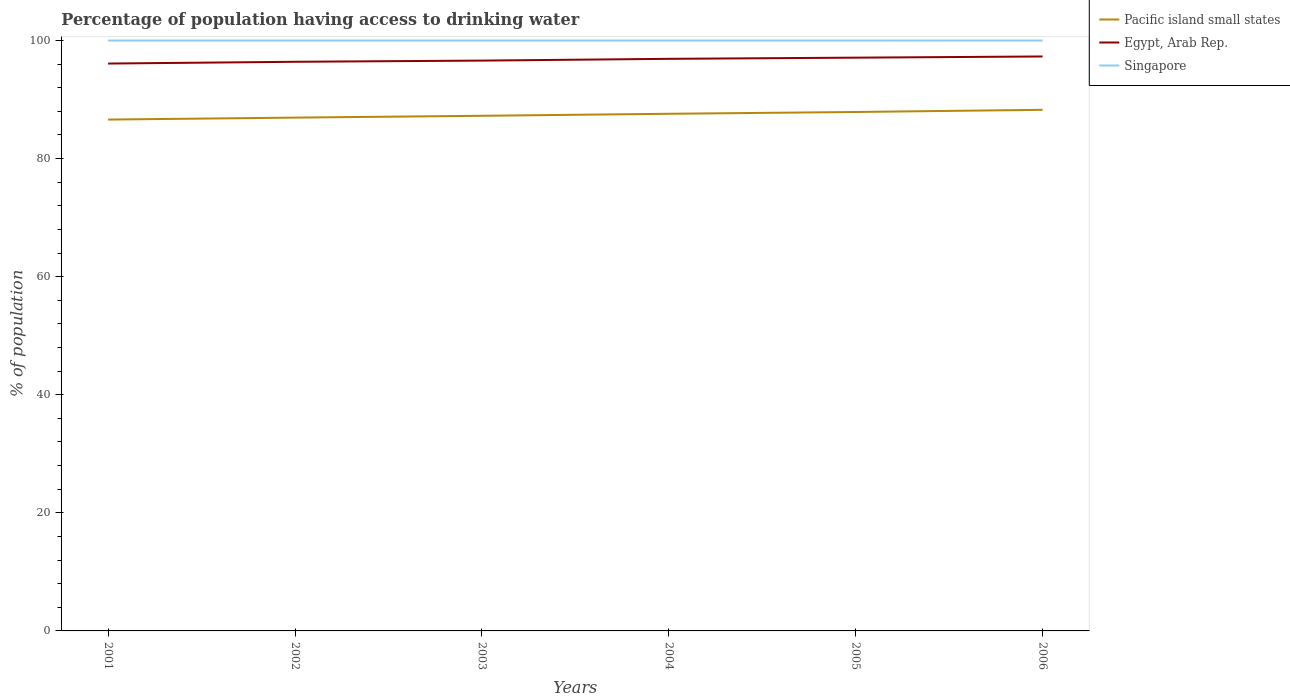Does the line corresponding to Egypt, Arab Rep. intersect with the line corresponding to Singapore?
Offer a terse response. No. Is the number of lines equal to the number of legend labels?
Offer a very short reply. Yes. Across all years, what is the maximum percentage of population having access to drinking water in Pacific island small states?
Make the answer very short. 86.61. What is the total percentage of population having access to drinking water in Egypt, Arab Rep. in the graph?
Provide a short and direct response. -0.8. What is the difference between the highest and the second highest percentage of population having access to drinking water in Egypt, Arab Rep.?
Provide a succinct answer. 1.2. Does the graph contain any zero values?
Your answer should be compact. No. What is the title of the graph?
Provide a short and direct response. Percentage of population having access to drinking water. Does "Brazil" appear as one of the legend labels in the graph?
Your response must be concise. No. What is the label or title of the X-axis?
Offer a very short reply. Years. What is the label or title of the Y-axis?
Your answer should be very brief. % of population. What is the % of population in Pacific island small states in 2001?
Keep it short and to the point. 86.61. What is the % of population of Egypt, Arab Rep. in 2001?
Give a very brief answer. 96.1. What is the % of population in Pacific island small states in 2002?
Offer a terse response. 86.94. What is the % of population in Egypt, Arab Rep. in 2002?
Give a very brief answer. 96.4. What is the % of population of Pacific island small states in 2003?
Your answer should be very brief. 87.25. What is the % of population in Egypt, Arab Rep. in 2003?
Offer a very short reply. 96.6. What is the % of population in Singapore in 2003?
Offer a very short reply. 100. What is the % of population in Pacific island small states in 2004?
Provide a short and direct response. 87.59. What is the % of population in Egypt, Arab Rep. in 2004?
Provide a succinct answer. 96.9. What is the % of population of Pacific island small states in 2005?
Keep it short and to the point. 87.9. What is the % of population in Egypt, Arab Rep. in 2005?
Provide a succinct answer. 97.1. What is the % of population in Singapore in 2005?
Give a very brief answer. 100. What is the % of population of Pacific island small states in 2006?
Offer a very short reply. 88.26. What is the % of population in Egypt, Arab Rep. in 2006?
Make the answer very short. 97.3. What is the % of population in Singapore in 2006?
Your answer should be compact. 100. Across all years, what is the maximum % of population in Pacific island small states?
Your answer should be very brief. 88.26. Across all years, what is the maximum % of population in Egypt, Arab Rep.?
Provide a short and direct response. 97.3. Across all years, what is the maximum % of population of Singapore?
Offer a very short reply. 100. Across all years, what is the minimum % of population of Pacific island small states?
Provide a succinct answer. 86.61. Across all years, what is the minimum % of population of Egypt, Arab Rep.?
Keep it short and to the point. 96.1. Across all years, what is the minimum % of population in Singapore?
Offer a terse response. 100. What is the total % of population of Pacific island small states in the graph?
Provide a succinct answer. 524.56. What is the total % of population of Egypt, Arab Rep. in the graph?
Offer a very short reply. 580.4. What is the total % of population of Singapore in the graph?
Offer a terse response. 600. What is the difference between the % of population of Pacific island small states in 2001 and that in 2002?
Make the answer very short. -0.33. What is the difference between the % of population in Singapore in 2001 and that in 2002?
Keep it short and to the point. 0. What is the difference between the % of population in Pacific island small states in 2001 and that in 2003?
Your response must be concise. -0.64. What is the difference between the % of population of Pacific island small states in 2001 and that in 2004?
Make the answer very short. -0.98. What is the difference between the % of population in Egypt, Arab Rep. in 2001 and that in 2004?
Offer a terse response. -0.8. What is the difference between the % of population of Pacific island small states in 2001 and that in 2005?
Provide a short and direct response. -1.28. What is the difference between the % of population in Egypt, Arab Rep. in 2001 and that in 2005?
Your response must be concise. -1. What is the difference between the % of population in Singapore in 2001 and that in 2005?
Offer a very short reply. 0. What is the difference between the % of population in Pacific island small states in 2001 and that in 2006?
Make the answer very short. -1.65. What is the difference between the % of population of Singapore in 2001 and that in 2006?
Offer a terse response. 0. What is the difference between the % of population in Pacific island small states in 2002 and that in 2003?
Your answer should be very brief. -0.31. What is the difference between the % of population in Egypt, Arab Rep. in 2002 and that in 2003?
Keep it short and to the point. -0.2. What is the difference between the % of population of Pacific island small states in 2002 and that in 2004?
Keep it short and to the point. -0.65. What is the difference between the % of population in Egypt, Arab Rep. in 2002 and that in 2004?
Keep it short and to the point. -0.5. What is the difference between the % of population of Singapore in 2002 and that in 2004?
Your answer should be very brief. 0. What is the difference between the % of population in Pacific island small states in 2002 and that in 2005?
Offer a very short reply. -0.95. What is the difference between the % of population of Singapore in 2002 and that in 2005?
Offer a very short reply. 0. What is the difference between the % of population in Pacific island small states in 2002 and that in 2006?
Your answer should be compact. -1.32. What is the difference between the % of population of Egypt, Arab Rep. in 2002 and that in 2006?
Give a very brief answer. -0.9. What is the difference between the % of population in Singapore in 2002 and that in 2006?
Ensure brevity in your answer.  0. What is the difference between the % of population of Pacific island small states in 2003 and that in 2004?
Your response must be concise. -0.34. What is the difference between the % of population of Egypt, Arab Rep. in 2003 and that in 2004?
Give a very brief answer. -0.3. What is the difference between the % of population in Singapore in 2003 and that in 2004?
Provide a succinct answer. 0. What is the difference between the % of population in Pacific island small states in 2003 and that in 2005?
Your response must be concise. -0.64. What is the difference between the % of population in Singapore in 2003 and that in 2005?
Provide a short and direct response. 0. What is the difference between the % of population of Pacific island small states in 2003 and that in 2006?
Make the answer very short. -1.01. What is the difference between the % of population in Egypt, Arab Rep. in 2003 and that in 2006?
Your answer should be very brief. -0.7. What is the difference between the % of population of Singapore in 2003 and that in 2006?
Give a very brief answer. 0. What is the difference between the % of population in Pacific island small states in 2004 and that in 2005?
Offer a very short reply. -0.3. What is the difference between the % of population in Pacific island small states in 2004 and that in 2006?
Make the answer very short. -0.67. What is the difference between the % of population in Egypt, Arab Rep. in 2004 and that in 2006?
Make the answer very short. -0.4. What is the difference between the % of population in Singapore in 2004 and that in 2006?
Your answer should be very brief. 0. What is the difference between the % of population of Pacific island small states in 2005 and that in 2006?
Your answer should be compact. -0.37. What is the difference between the % of population in Pacific island small states in 2001 and the % of population in Egypt, Arab Rep. in 2002?
Provide a succinct answer. -9.79. What is the difference between the % of population of Pacific island small states in 2001 and the % of population of Singapore in 2002?
Make the answer very short. -13.39. What is the difference between the % of population of Pacific island small states in 2001 and the % of population of Egypt, Arab Rep. in 2003?
Your answer should be compact. -9.99. What is the difference between the % of population of Pacific island small states in 2001 and the % of population of Singapore in 2003?
Ensure brevity in your answer.  -13.39. What is the difference between the % of population of Egypt, Arab Rep. in 2001 and the % of population of Singapore in 2003?
Provide a succinct answer. -3.9. What is the difference between the % of population of Pacific island small states in 2001 and the % of population of Egypt, Arab Rep. in 2004?
Keep it short and to the point. -10.29. What is the difference between the % of population of Pacific island small states in 2001 and the % of population of Singapore in 2004?
Provide a short and direct response. -13.39. What is the difference between the % of population of Pacific island small states in 2001 and the % of population of Egypt, Arab Rep. in 2005?
Make the answer very short. -10.49. What is the difference between the % of population in Pacific island small states in 2001 and the % of population in Singapore in 2005?
Provide a short and direct response. -13.39. What is the difference between the % of population in Pacific island small states in 2001 and the % of population in Egypt, Arab Rep. in 2006?
Give a very brief answer. -10.69. What is the difference between the % of population in Pacific island small states in 2001 and the % of population in Singapore in 2006?
Provide a short and direct response. -13.39. What is the difference between the % of population in Pacific island small states in 2002 and the % of population in Egypt, Arab Rep. in 2003?
Give a very brief answer. -9.66. What is the difference between the % of population of Pacific island small states in 2002 and the % of population of Singapore in 2003?
Your response must be concise. -13.06. What is the difference between the % of population of Egypt, Arab Rep. in 2002 and the % of population of Singapore in 2003?
Offer a terse response. -3.6. What is the difference between the % of population of Pacific island small states in 2002 and the % of population of Egypt, Arab Rep. in 2004?
Give a very brief answer. -9.96. What is the difference between the % of population of Pacific island small states in 2002 and the % of population of Singapore in 2004?
Offer a terse response. -13.06. What is the difference between the % of population in Egypt, Arab Rep. in 2002 and the % of population in Singapore in 2004?
Your answer should be very brief. -3.6. What is the difference between the % of population in Pacific island small states in 2002 and the % of population in Egypt, Arab Rep. in 2005?
Provide a succinct answer. -10.16. What is the difference between the % of population in Pacific island small states in 2002 and the % of population in Singapore in 2005?
Offer a terse response. -13.06. What is the difference between the % of population of Egypt, Arab Rep. in 2002 and the % of population of Singapore in 2005?
Give a very brief answer. -3.6. What is the difference between the % of population of Pacific island small states in 2002 and the % of population of Egypt, Arab Rep. in 2006?
Your response must be concise. -10.36. What is the difference between the % of population of Pacific island small states in 2002 and the % of population of Singapore in 2006?
Offer a very short reply. -13.06. What is the difference between the % of population in Pacific island small states in 2003 and the % of population in Egypt, Arab Rep. in 2004?
Ensure brevity in your answer.  -9.65. What is the difference between the % of population in Pacific island small states in 2003 and the % of population in Singapore in 2004?
Offer a very short reply. -12.75. What is the difference between the % of population of Egypt, Arab Rep. in 2003 and the % of population of Singapore in 2004?
Your answer should be compact. -3.4. What is the difference between the % of population of Pacific island small states in 2003 and the % of population of Egypt, Arab Rep. in 2005?
Offer a very short reply. -9.85. What is the difference between the % of population in Pacific island small states in 2003 and the % of population in Singapore in 2005?
Give a very brief answer. -12.75. What is the difference between the % of population of Pacific island small states in 2003 and the % of population of Egypt, Arab Rep. in 2006?
Your answer should be very brief. -10.05. What is the difference between the % of population of Pacific island small states in 2003 and the % of population of Singapore in 2006?
Your response must be concise. -12.75. What is the difference between the % of population in Egypt, Arab Rep. in 2003 and the % of population in Singapore in 2006?
Provide a succinct answer. -3.4. What is the difference between the % of population of Pacific island small states in 2004 and the % of population of Egypt, Arab Rep. in 2005?
Provide a succinct answer. -9.51. What is the difference between the % of population of Pacific island small states in 2004 and the % of population of Singapore in 2005?
Ensure brevity in your answer.  -12.41. What is the difference between the % of population in Pacific island small states in 2004 and the % of population in Egypt, Arab Rep. in 2006?
Give a very brief answer. -9.71. What is the difference between the % of population of Pacific island small states in 2004 and the % of population of Singapore in 2006?
Provide a short and direct response. -12.41. What is the difference between the % of population of Egypt, Arab Rep. in 2004 and the % of population of Singapore in 2006?
Your answer should be very brief. -3.1. What is the difference between the % of population of Pacific island small states in 2005 and the % of population of Egypt, Arab Rep. in 2006?
Give a very brief answer. -9.4. What is the difference between the % of population in Pacific island small states in 2005 and the % of population in Singapore in 2006?
Your answer should be compact. -12.1. What is the difference between the % of population in Egypt, Arab Rep. in 2005 and the % of population in Singapore in 2006?
Keep it short and to the point. -2.9. What is the average % of population in Pacific island small states per year?
Give a very brief answer. 87.43. What is the average % of population in Egypt, Arab Rep. per year?
Provide a short and direct response. 96.73. In the year 2001, what is the difference between the % of population of Pacific island small states and % of population of Egypt, Arab Rep.?
Make the answer very short. -9.49. In the year 2001, what is the difference between the % of population of Pacific island small states and % of population of Singapore?
Offer a terse response. -13.39. In the year 2002, what is the difference between the % of population in Pacific island small states and % of population in Egypt, Arab Rep.?
Give a very brief answer. -9.46. In the year 2002, what is the difference between the % of population of Pacific island small states and % of population of Singapore?
Your answer should be compact. -13.06. In the year 2002, what is the difference between the % of population of Egypt, Arab Rep. and % of population of Singapore?
Your answer should be compact. -3.6. In the year 2003, what is the difference between the % of population of Pacific island small states and % of population of Egypt, Arab Rep.?
Offer a very short reply. -9.35. In the year 2003, what is the difference between the % of population in Pacific island small states and % of population in Singapore?
Keep it short and to the point. -12.75. In the year 2004, what is the difference between the % of population of Pacific island small states and % of population of Egypt, Arab Rep.?
Keep it short and to the point. -9.31. In the year 2004, what is the difference between the % of population of Pacific island small states and % of population of Singapore?
Your answer should be compact. -12.41. In the year 2005, what is the difference between the % of population in Pacific island small states and % of population in Egypt, Arab Rep.?
Your answer should be very brief. -9.2. In the year 2005, what is the difference between the % of population in Pacific island small states and % of population in Singapore?
Provide a succinct answer. -12.1. In the year 2006, what is the difference between the % of population of Pacific island small states and % of population of Egypt, Arab Rep.?
Give a very brief answer. -9.04. In the year 2006, what is the difference between the % of population of Pacific island small states and % of population of Singapore?
Give a very brief answer. -11.74. What is the ratio of the % of population in Egypt, Arab Rep. in 2001 to that in 2002?
Your answer should be very brief. 1. What is the ratio of the % of population in Singapore in 2001 to that in 2002?
Your response must be concise. 1. What is the ratio of the % of population in Singapore in 2001 to that in 2003?
Your response must be concise. 1. What is the ratio of the % of population in Singapore in 2001 to that in 2004?
Make the answer very short. 1. What is the ratio of the % of population in Pacific island small states in 2001 to that in 2005?
Provide a short and direct response. 0.99. What is the ratio of the % of population in Egypt, Arab Rep. in 2001 to that in 2005?
Your response must be concise. 0.99. What is the ratio of the % of population in Pacific island small states in 2001 to that in 2006?
Provide a short and direct response. 0.98. What is the ratio of the % of population in Egypt, Arab Rep. in 2002 to that in 2003?
Provide a succinct answer. 1. What is the ratio of the % of population of Egypt, Arab Rep. in 2002 to that in 2004?
Offer a terse response. 0.99. What is the ratio of the % of population of Singapore in 2002 to that in 2005?
Offer a very short reply. 1. What is the ratio of the % of population in Pacific island small states in 2002 to that in 2006?
Your answer should be compact. 0.99. What is the ratio of the % of population in Egypt, Arab Rep. in 2002 to that in 2006?
Offer a very short reply. 0.99. What is the ratio of the % of population in Egypt, Arab Rep. in 2003 to that in 2005?
Your response must be concise. 0.99. What is the ratio of the % of population of Singapore in 2003 to that in 2005?
Ensure brevity in your answer.  1. What is the ratio of the % of population of Pacific island small states in 2003 to that in 2006?
Offer a terse response. 0.99. What is the ratio of the % of population in Egypt, Arab Rep. in 2003 to that in 2006?
Give a very brief answer. 0.99. What is the ratio of the % of population in Singapore in 2003 to that in 2006?
Ensure brevity in your answer.  1. What is the ratio of the % of population of Pacific island small states in 2004 to that in 2005?
Keep it short and to the point. 1. What is the ratio of the % of population in Egypt, Arab Rep. in 2004 to that in 2006?
Your answer should be very brief. 1. What is the ratio of the % of population of Pacific island small states in 2005 to that in 2006?
Make the answer very short. 1. What is the ratio of the % of population in Singapore in 2005 to that in 2006?
Ensure brevity in your answer.  1. What is the difference between the highest and the second highest % of population in Pacific island small states?
Your answer should be very brief. 0.37. What is the difference between the highest and the lowest % of population in Pacific island small states?
Give a very brief answer. 1.65. What is the difference between the highest and the lowest % of population in Egypt, Arab Rep.?
Offer a terse response. 1.2. 